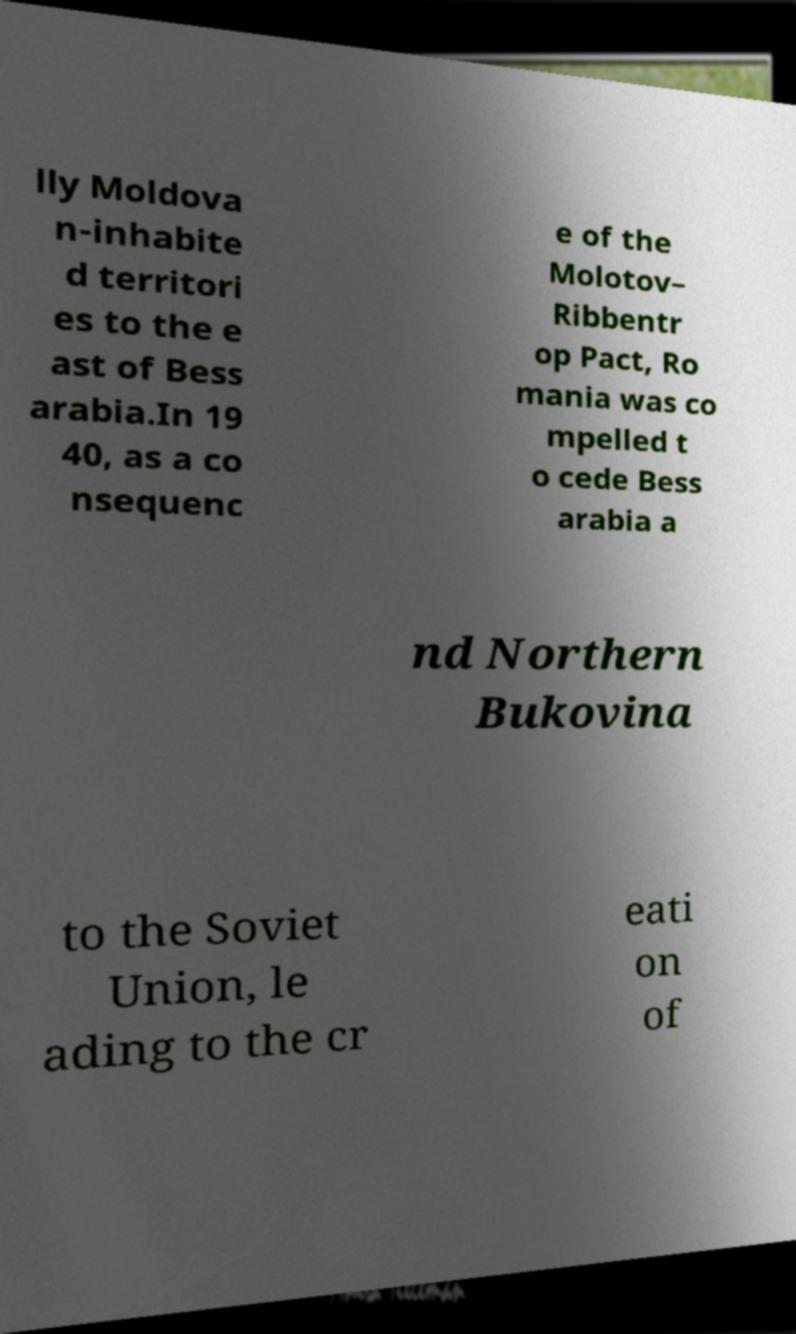For documentation purposes, I need the text within this image transcribed. Could you provide that? lly Moldova n-inhabite d territori es to the e ast of Bess arabia.In 19 40, as a co nsequenc e of the Molotov– Ribbentr op Pact, Ro mania was co mpelled t o cede Bess arabia a nd Northern Bukovina to the Soviet Union, le ading to the cr eati on of 